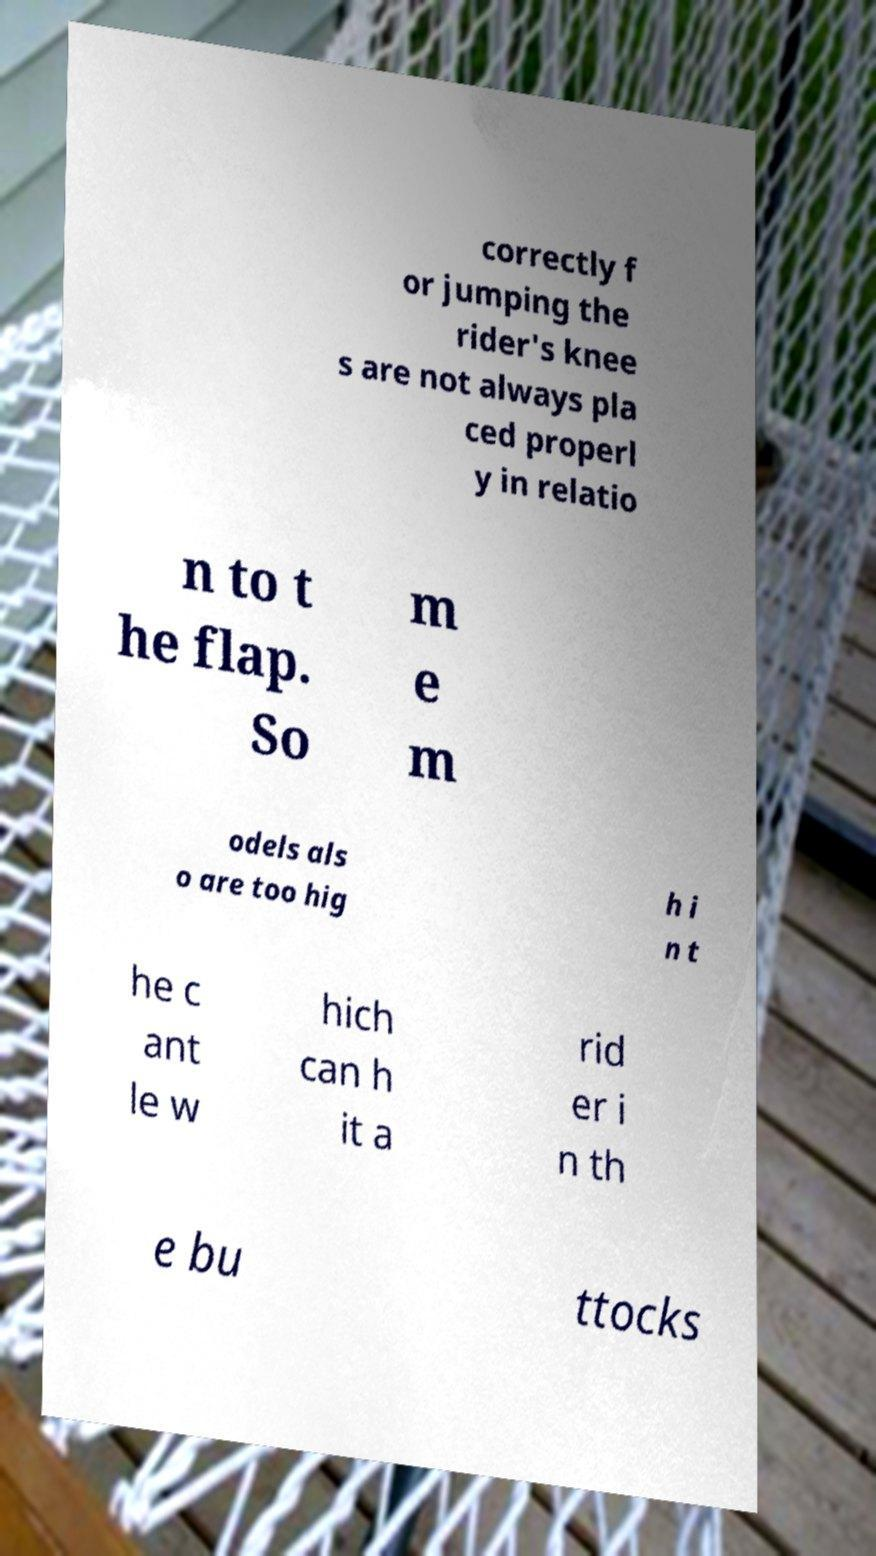I need the written content from this picture converted into text. Can you do that? correctly f or jumping the rider's knee s are not always pla ced properl y in relatio n to t he flap. So m e m odels als o are too hig h i n t he c ant le w hich can h it a rid er i n th e bu ttocks 